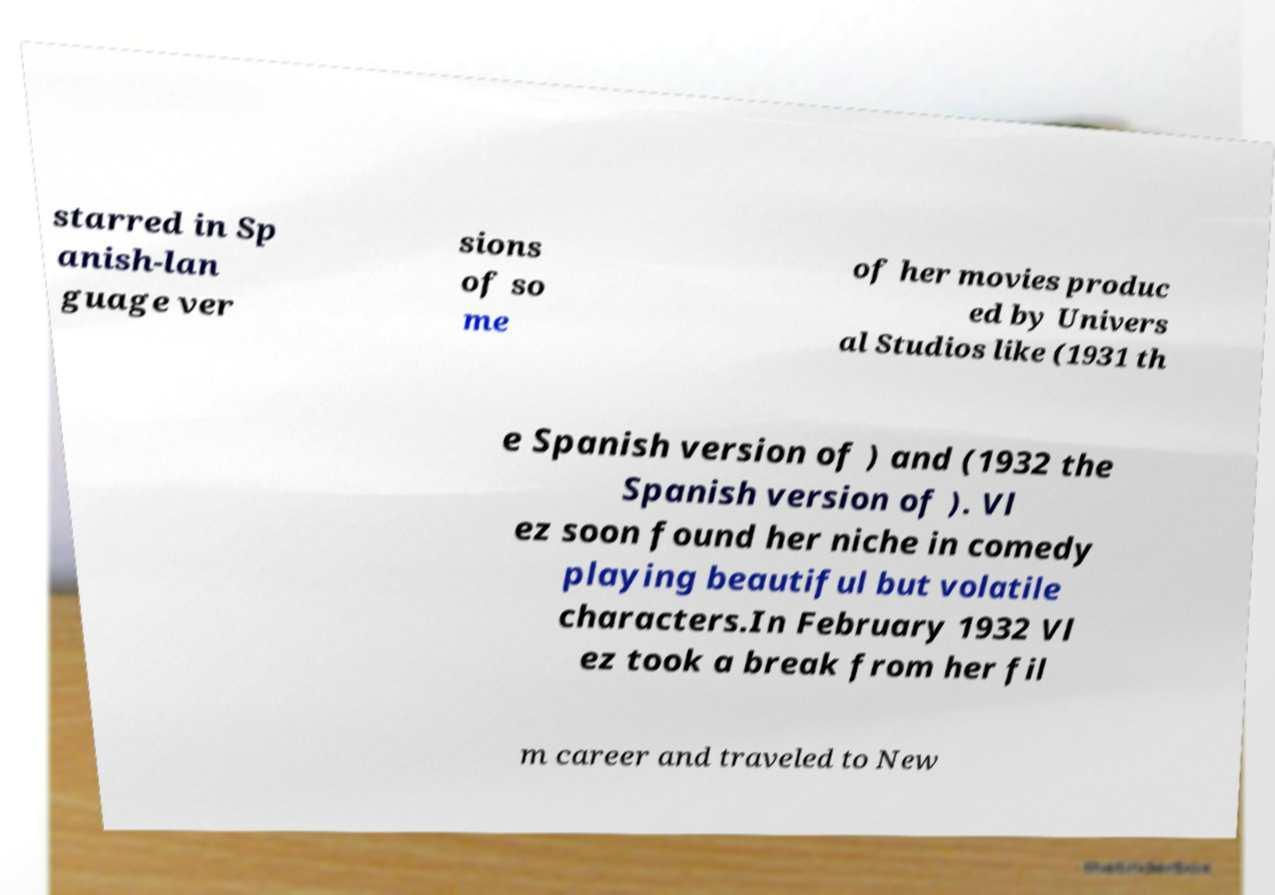I need the written content from this picture converted into text. Can you do that? starred in Sp anish-lan guage ver sions of so me of her movies produc ed by Univers al Studios like (1931 th e Spanish version of ) and (1932 the Spanish version of ). Vl ez soon found her niche in comedy playing beautiful but volatile characters.In February 1932 Vl ez took a break from her fil m career and traveled to New 